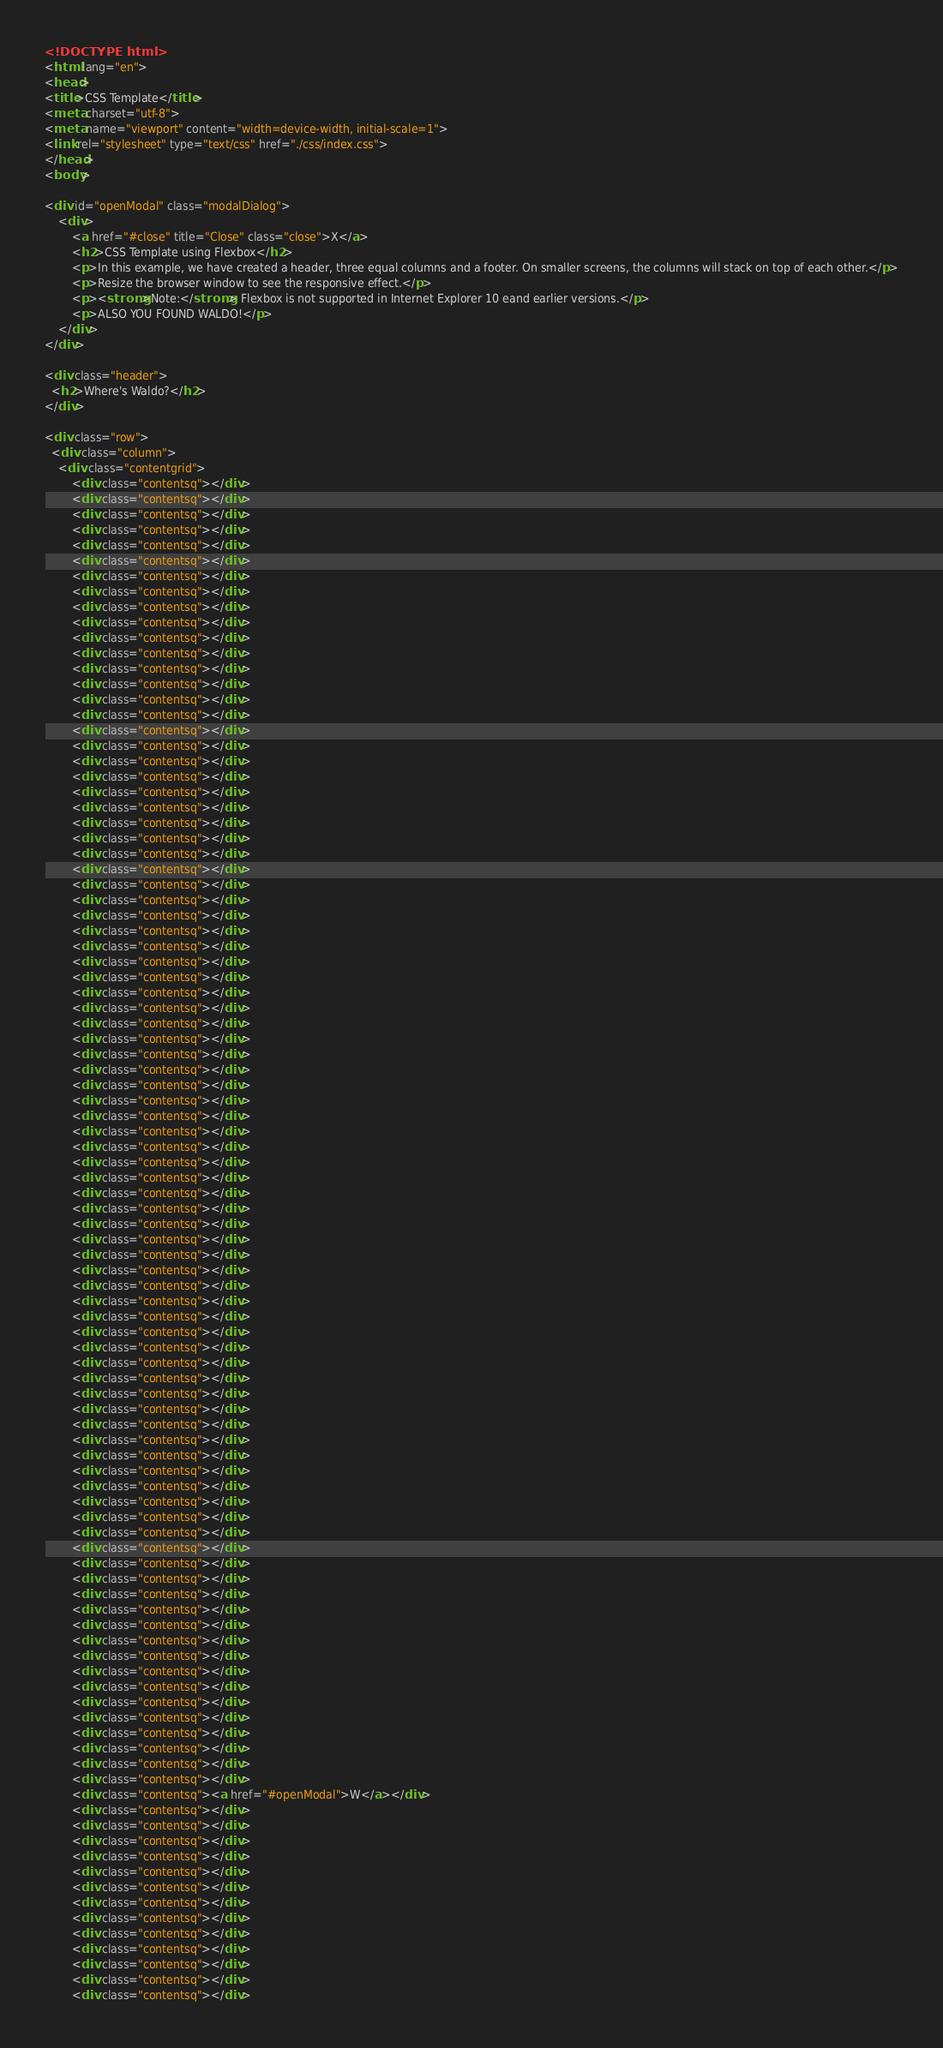Convert code to text. <code><loc_0><loc_0><loc_500><loc_500><_HTML_><!DOCTYPE html>
<html lang="en">
<head>
<title>CSS Template</title>
<meta charset="utf-8">
<meta name="viewport" content="width=device-width, initial-scale=1">
<link rel="stylesheet" type="text/css" href="./css/index.css">
</head>
<body>

<div id="openModal" class="modalDialog">
    <div>
        <a href="#close" title="Close" class="close">X</a>
        <h2>CSS Template using Flexbox</h2>
        <p>In this example, we have created a header, three equal columns and a footer. On smaller screens, the columns will stack on top of each other.</p>
        <p>Resize the browser window to see the responsive effect.</p>
        <p><strong>Note:</strong> Flexbox is not supported in Internet Explorer 10 eand earlier versions.</p>
        <p>ALSO YOU FOUND WALDO!</p>
    </div>
</div>

<div class="header">
  <h2>Where's Waldo?</h2>
</div>

<div class="row">
  <div class="column">
    <div class="contentgrid">
        <div class="contentsq"></div>
        <div class="contentsq"></div>
        <div class="contentsq"></div>
        <div class="contentsq"></div>
        <div class="contentsq"></div>
        <div class="contentsq"></div>
        <div class="contentsq"></div>
        <div class="contentsq"></div>
        <div class="contentsq"></div>
        <div class="contentsq"></div>
        <div class="contentsq"></div>
        <div class="contentsq"></div>
        <div class="contentsq"></div>
        <div class="contentsq"></div>
        <div class="contentsq"></div>
        <div class="contentsq"></div>
        <div class="contentsq"></div>
        <div class="contentsq"></div>
        <div class="contentsq"></div>
        <div class="contentsq"></div>
        <div class="contentsq"></div>
        <div class="contentsq"></div>
        <div class="contentsq"></div>
        <div class="contentsq"></div>
        <div class="contentsq"></div>
        <div class="contentsq"></div>
        <div class="contentsq"></div>
        <div class="contentsq"></div>
        <div class="contentsq"></div>
        <div class="contentsq"></div>
        <div class="contentsq"></div>
        <div class="contentsq"></div>
        <div class="contentsq"></div>
        <div class="contentsq"></div>
        <div class="contentsq"></div>
        <div class="contentsq"></div>
        <div class="contentsq"></div>
        <div class="contentsq"></div>
        <div class="contentsq"></div>
        <div class="contentsq"></div>
        <div class="contentsq"></div>
        <div class="contentsq"></div>
        <div class="contentsq"></div>
        <div class="contentsq"></div>
        <div class="contentsq"></div>
        <div class="contentsq"></div>
        <div class="contentsq"></div>
        <div class="contentsq"></div>
        <div class="contentsq"></div>
        <div class="contentsq"></div>
        <div class="contentsq"></div>
        <div class="contentsq"></div>
        <div class="contentsq"></div>
        <div class="contentsq"></div>
        <div class="contentsq"></div>
        <div class="contentsq"></div>
        <div class="contentsq"></div>
        <div class="contentsq"></div>
        <div class="contentsq"></div>
        <div class="contentsq"></div>
        <div class="contentsq"></div>
        <div class="contentsq"></div>
        <div class="contentsq"></div>
        <div class="contentsq"></div>
        <div class="contentsq"></div>
        <div class="contentsq"></div>
        <div class="contentsq"></div>
        <div class="contentsq"></div>
        <div class="contentsq"></div>
        <div class="contentsq"></div>
        <div class="contentsq"></div>
        <div class="contentsq"></div>
        <div class="contentsq"></div>
        <div class="contentsq"></div>
        <div class="contentsq"></div>
        <div class="contentsq"></div>
        <div class="contentsq"></div>
        <div class="contentsq"></div>
        <div class="contentsq"></div>
        <div class="contentsq"></div>
        <div class="contentsq"></div>
        <div class="contentsq"></div>
        <div class="contentsq"></div>
        <div class="contentsq"></div>
        <div class="contentsq"></div>
        <div class="contentsq"><a href="#openModal">W</a></div>
        <div class="contentsq"></div>
        <div class="contentsq"></div>
        <div class="contentsq"></div>
        <div class="contentsq"></div>
        <div class="contentsq"></div>
        <div class="contentsq"></div>
        <div class="contentsq"></div>
        <div class="contentsq"></div>
        <div class="contentsq"></div>
        <div class="contentsq"></div>
        <div class="contentsq"></div>
        <div class="contentsq"></div>
        <div class="contentsq"></div></code> 